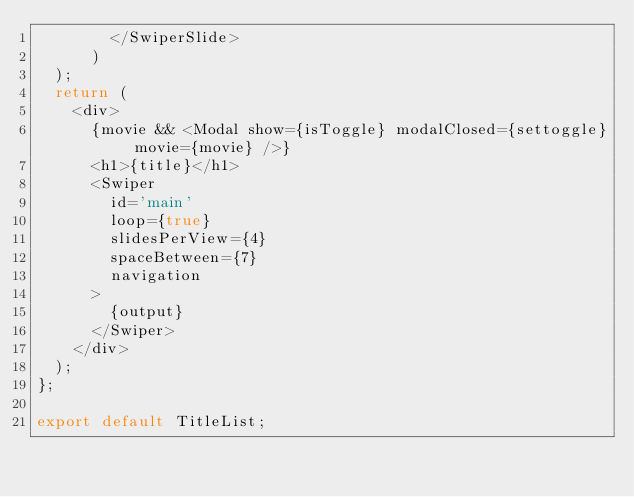<code> <loc_0><loc_0><loc_500><loc_500><_JavaScript_>        </SwiperSlide>
      )
  );
  return (
    <div>
      {movie && <Modal show={isToggle} modalClosed={settoggle} movie={movie} />}
      <h1>{title}</h1>
      <Swiper
        id='main'
        loop={true}
        slidesPerView={4}
        spaceBetween={7}
        navigation
      >
        {output}
      </Swiper>
    </div>
  );
};

export default TitleList;
</code> 